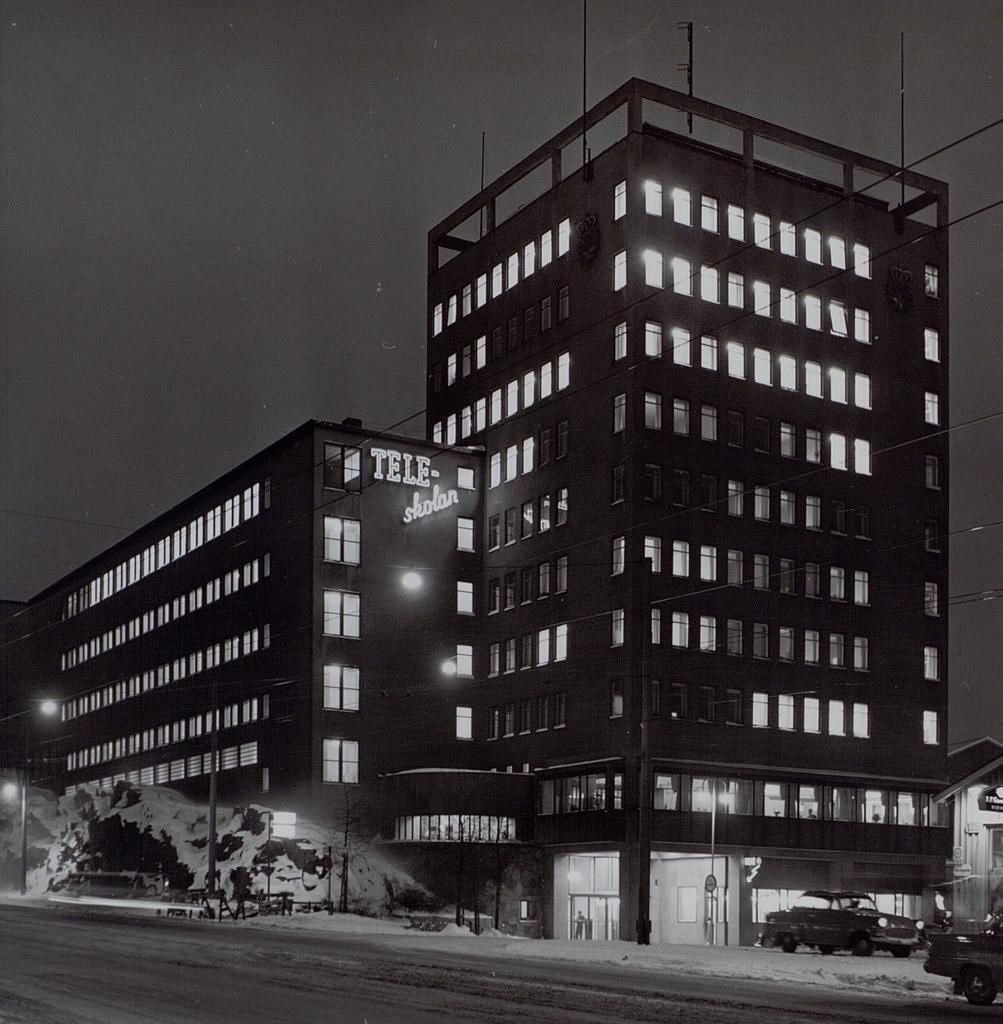Describe this image in one or two sentences. This picture is clicked outside. In the foreground we can see the vehicles, poles, lights and some other objects. In the center we can see the buildings and the text on the building. In the background we can see the sky and the cables and some other objects. 